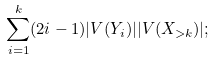Convert formula to latex. <formula><loc_0><loc_0><loc_500><loc_500>\sum _ { i = 1 } ^ { k } ( 2 i - 1 ) | V ( Y _ { i } ) | | V ( X _ { > k } ) | ;</formula> 